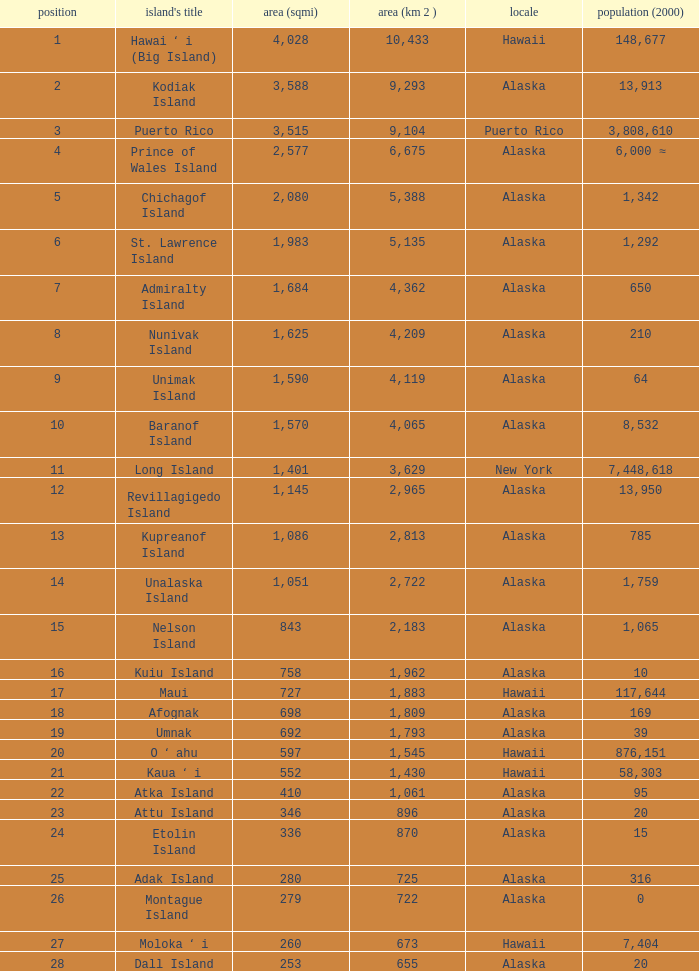Parse the table in full. {'header': ['position', "island's title", 'area (sqmi)', 'area (km 2 )', 'locale', 'population (2000)'], 'rows': [['1', 'Hawai ʻ i (Big Island)', '4,028', '10,433', 'Hawaii', '148,677'], ['2', 'Kodiak Island', '3,588', '9,293', 'Alaska', '13,913'], ['3', 'Puerto Rico', '3,515', '9,104', 'Puerto Rico', '3,808,610'], ['4', 'Prince of Wales Island', '2,577', '6,675', 'Alaska', '6,000 ≈'], ['5', 'Chichagof Island', '2,080', '5,388', 'Alaska', '1,342'], ['6', 'St. Lawrence Island', '1,983', '5,135', 'Alaska', '1,292'], ['7', 'Admiralty Island', '1,684', '4,362', 'Alaska', '650'], ['8', 'Nunivak Island', '1,625', '4,209', 'Alaska', '210'], ['9', 'Unimak Island', '1,590', '4,119', 'Alaska', '64'], ['10', 'Baranof Island', '1,570', '4,065', 'Alaska', '8,532'], ['11', 'Long Island', '1,401', '3,629', 'New York', '7,448,618'], ['12', 'Revillagigedo Island', '1,145', '2,965', 'Alaska', '13,950'], ['13', 'Kupreanof Island', '1,086', '2,813', 'Alaska', '785'], ['14', 'Unalaska Island', '1,051', '2,722', 'Alaska', '1,759'], ['15', 'Nelson Island', '843', '2,183', 'Alaska', '1,065'], ['16', 'Kuiu Island', '758', '1,962', 'Alaska', '10'], ['17', 'Maui', '727', '1,883', 'Hawaii', '117,644'], ['18', 'Afognak', '698', '1,809', 'Alaska', '169'], ['19', 'Umnak', '692', '1,793', 'Alaska', '39'], ['20', 'O ʻ ahu', '597', '1,545', 'Hawaii', '876,151'], ['21', 'Kaua ʻ i', '552', '1,430', 'Hawaii', '58,303'], ['22', 'Atka Island', '410', '1,061', 'Alaska', '95'], ['23', 'Attu Island', '346', '896', 'Alaska', '20'], ['24', 'Etolin Island', '336', '870', 'Alaska', '15'], ['25', 'Adak Island', '280', '725', 'Alaska', '316'], ['26', 'Montague Island', '279', '722', 'Alaska', '0'], ['27', 'Moloka ʻ i', '260', '673', 'Hawaii', '7,404'], ['28', 'Dall Island', '253', '655', 'Alaska', '20']]} What is the largest area in Alaska with a population of 39 and rank over 19? None. 